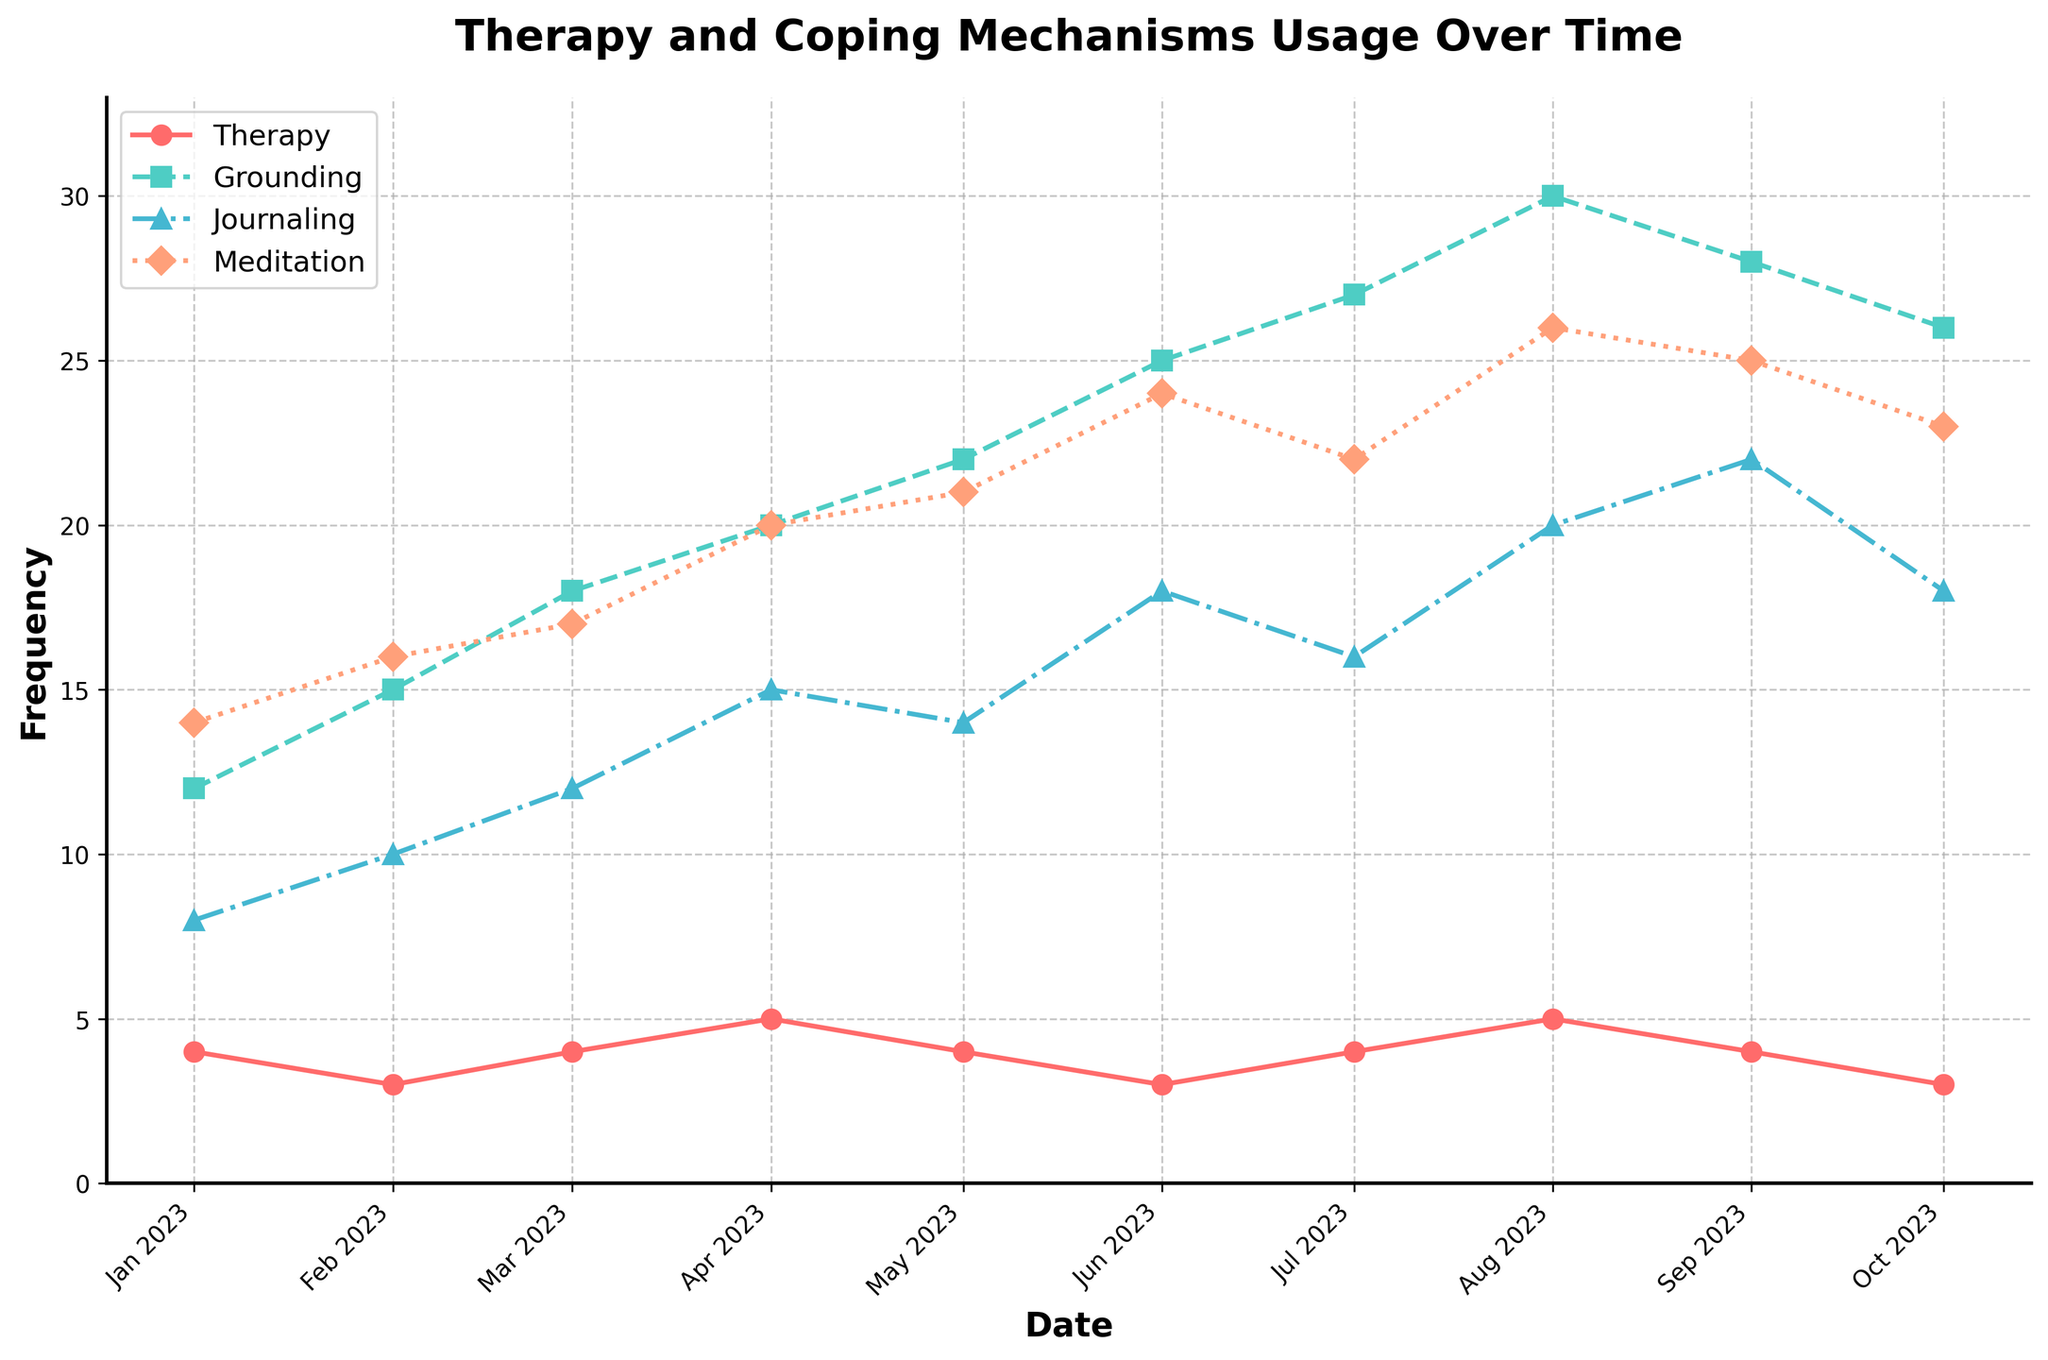What is the title of the figure? The title is displayed at the top of the figure in bold text. It provides a summary of the content of the graph.
Answer: Therapy and Coping Mechanisms Usage Over Time What is the frequency of therapy sessions in January 2023? Locate January 2023 on the x-axis and look at the corresponding point for the therapy sessions.
Answer: 4 sessions/month Which coping mechanism shows the highest usage in August 2023? Find August 2023 on the x-axis and compare the values of grounding techniques, journaling, and meditation.
Answer: Grounding techniques Between which months did the journaling frequency increase the most? Observe the points for journaling and identify the month with the biggest jump in the frequency.
Answer: June to July 2023 What are the minimum and maximum values for the meditation sessions over the time period? Look for the lowest and highest points for the meditation line over the entire date range.
Answer: Min: 14, Max: 26 How did the frequency of grounding techniques usage change from June 2023 to October 2023? Compare the grounding techniques usage values in June and October 2023.
Answer: It decreased from 25 to 26 times/month Which month showed the highest frequency of therapy sessions? Find the highest point on the therapy sessions line and note the corresponding month.
Answer: April 2023 and August 2023 What is the average frequency of journaling entries from January 2023 to October 2023? Sum the journaling frequency for all months and divide by the number of months. (8+10+12+15+14+18+16+20+22+18)/10 = 15.3
Answer: 15.3 entries/month Which month had the lowest frequency of grounding techniques usage, and what was it? Locate the lowest point on the grounding techniques line and find the corresponding month.
Answer: January 2023, 12 times/month Compare the trends of therapy sessions and meditation sessions from January to October 2023. How do they relate? Evaluate the lines for therapy and meditation sessions over this period, noting any similar trends or divergences.
Answer: Both generally increase over time, with therapy showing more variation Is there a month where all coping mechanisms (grounding, journaling, meditation) show an increase compared to the previous month? Which month? Compare each month to its previous one for all three indicators: grounding techniques, journaling, and meditation.
Answer: March 2023 